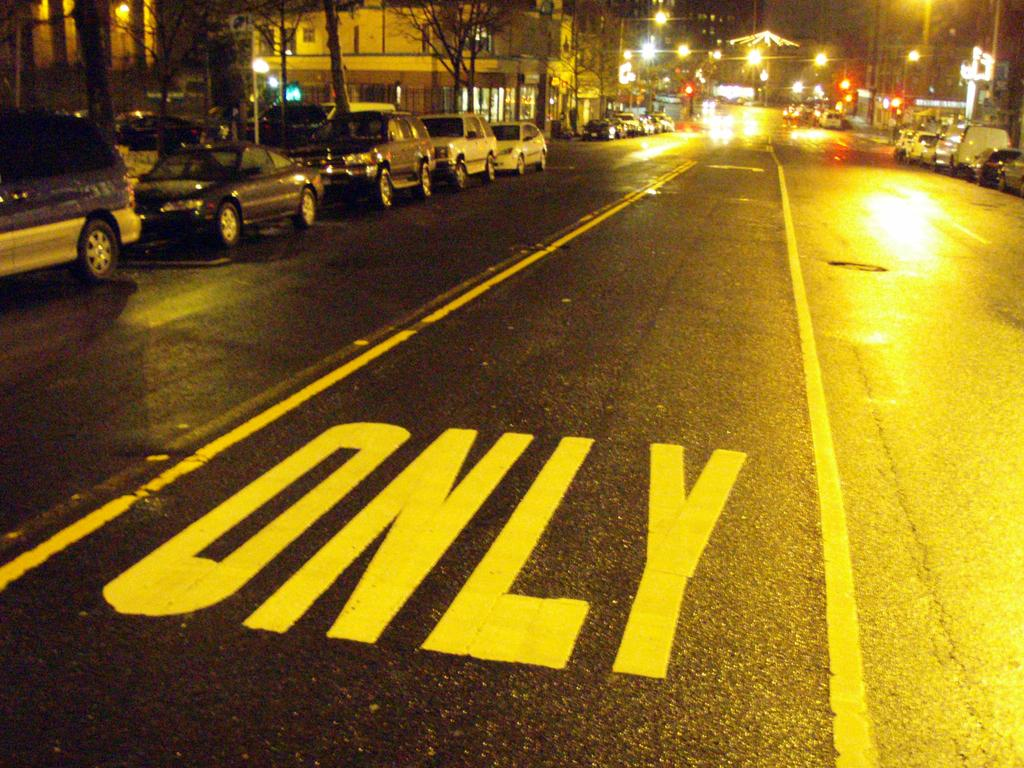Provide a one-sentence caption for the provided image. A street with One Way Only written on it is shown. 